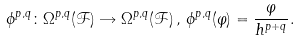<formula> <loc_0><loc_0><loc_500><loc_500>\phi ^ { p , q } \colon \Omega ^ { p , q } ( \mathcal { F } ) \rightarrow \Omega ^ { p , q } ( \mathcal { F } ) \, , \, \phi ^ { p , q } ( \varphi ) = \frac { \varphi } { h ^ { p + q } } .</formula> 